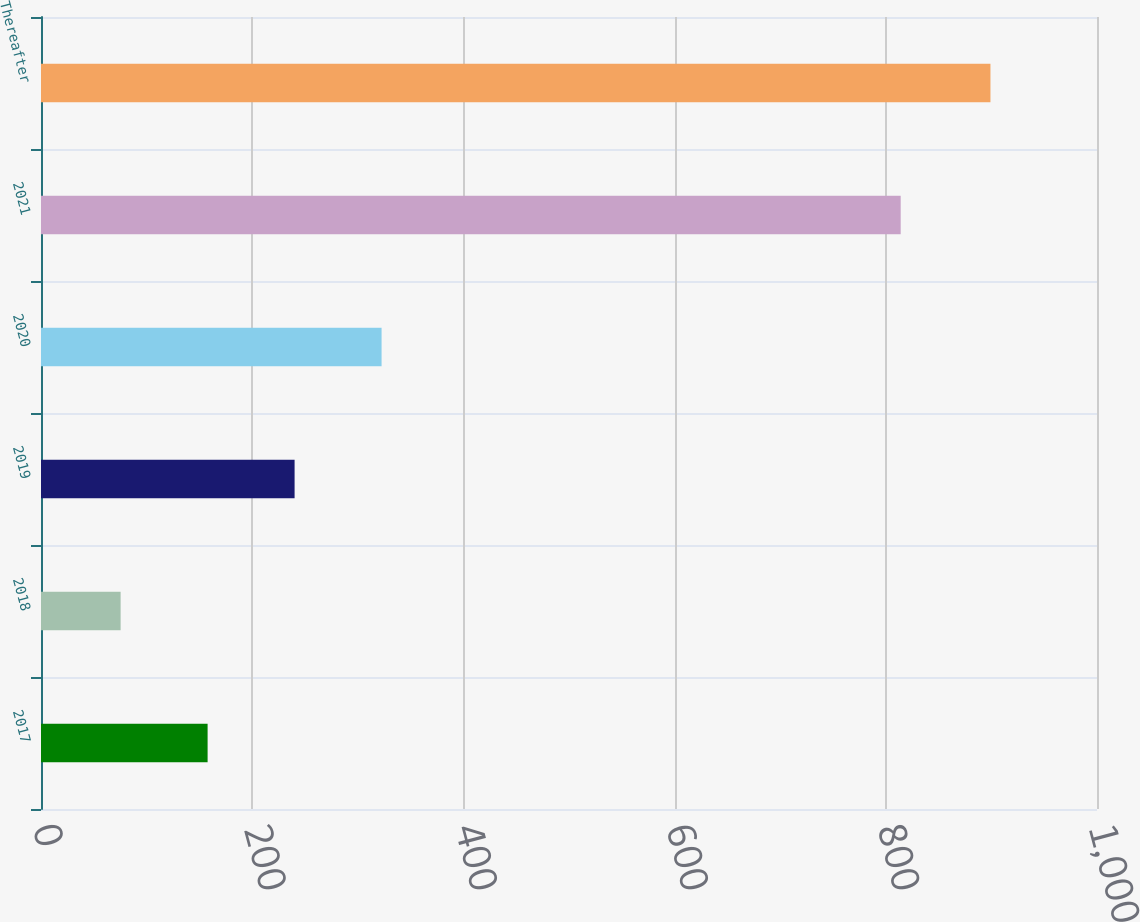Convert chart to OTSL. <chart><loc_0><loc_0><loc_500><loc_500><bar_chart><fcel>2017<fcel>2018<fcel>2019<fcel>2020<fcel>2021<fcel>Thereafter<nl><fcel>157.77<fcel>75.4<fcel>240.14<fcel>322.51<fcel>814.1<fcel>899.1<nl></chart> 